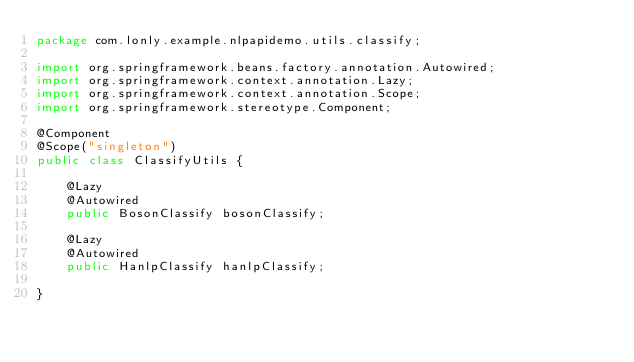Convert code to text. <code><loc_0><loc_0><loc_500><loc_500><_Java_>package com.lonly.example.nlpapidemo.utils.classify;

import org.springframework.beans.factory.annotation.Autowired;
import org.springframework.context.annotation.Lazy;
import org.springframework.context.annotation.Scope;
import org.springframework.stereotype.Component;

@Component
@Scope("singleton")
public class ClassifyUtils {

    @Lazy
    @Autowired
    public BosonClassify bosonClassify;

    @Lazy
    @Autowired
    public HanlpClassify hanlpClassify;

}
</code> 